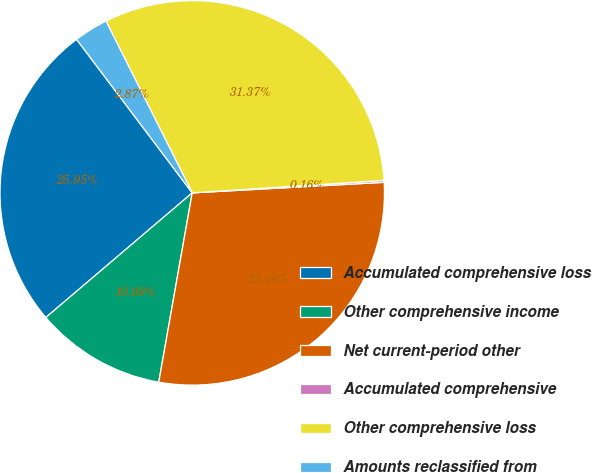Convert chart. <chart><loc_0><loc_0><loc_500><loc_500><pie_chart><fcel>Accumulated comprehensive loss<fcel>Other comprehensive income<fcel>Net current-period other<fcel>Accumulated comprehensive<fcel>Other comprehensive loss<fcel>Amounts reclassified from<nl><fcel>25.95%<fcel>10.99%<fcel>28.66%<fcel>0.16%<fcel>31.37%<fcel>2.87%<nl></chart> 